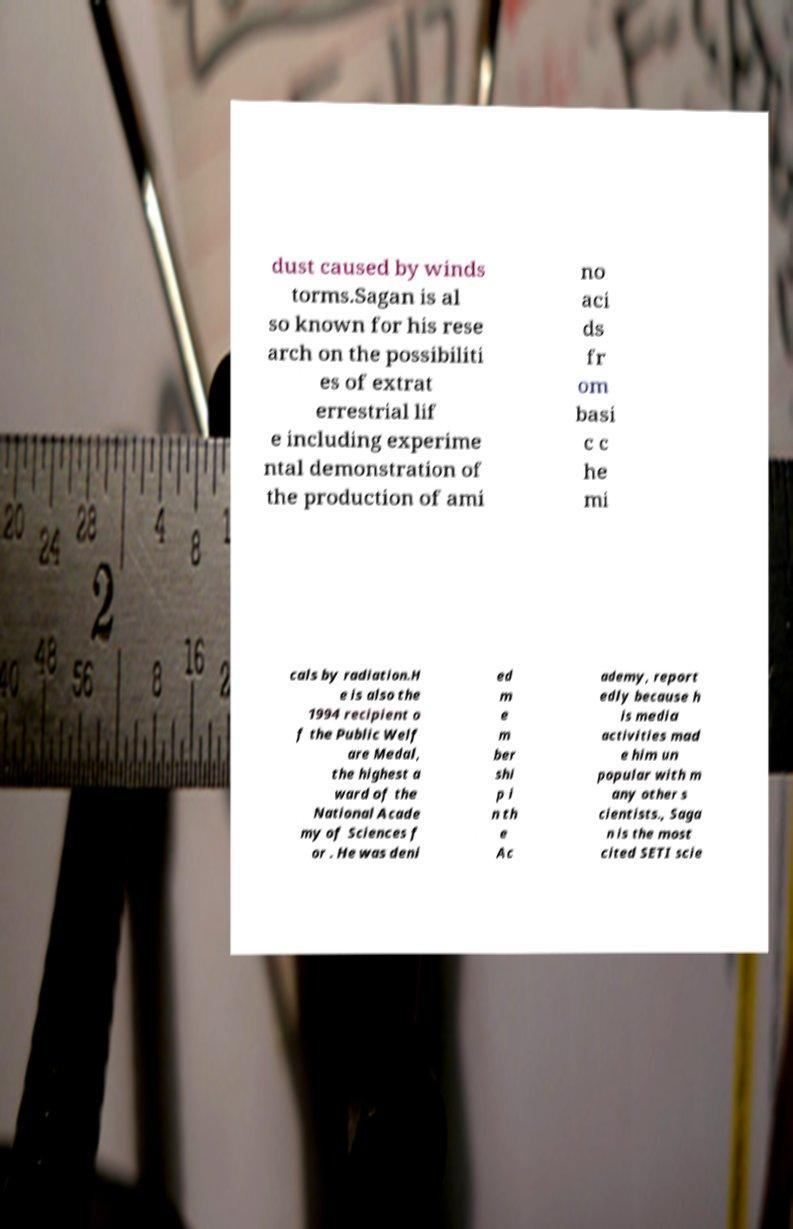There's text embedded in this image that I need extracted. Can you transcribe it verbatim? dust caused by winds torms.Sagan is al so known for his rese arch on the possibiliti es of extrat errestrial lif e including experime ntal demonstration of the production of ami no aci ds fr om basi c c he mi cals by radiation.H e is also the 1994 recipient o f the Public Welf are Medal, the highest a ward of the National Acade my of Sciences f or . He was deni ed m e m ber shi p i n th e Ac ademy, report edly because h is media activities mad e him un popular with m any other s cientists., Saga n is the most cited SETI scie 